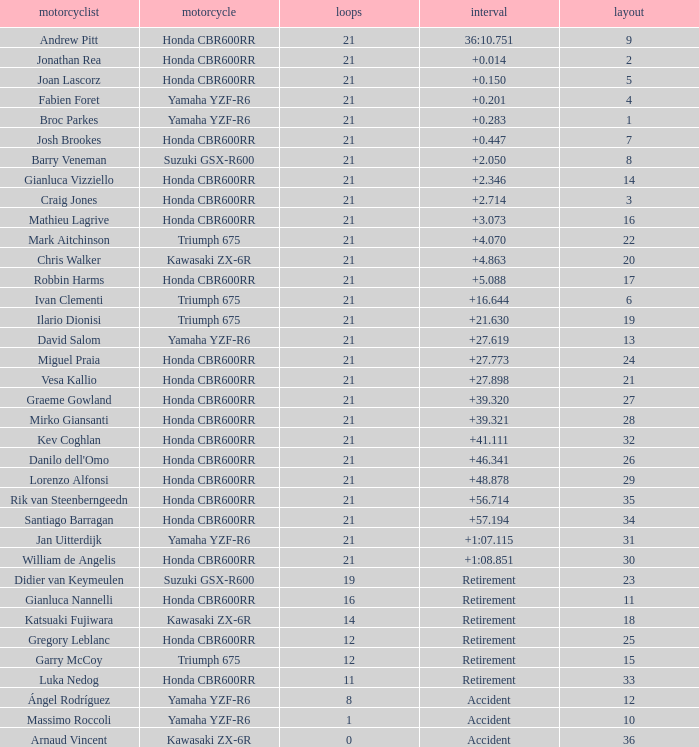What is the driver with the laps under 16, grid of 10, a bike of Yamaha YZF-R6, and ended with an accident? Massimo Roccoli. 